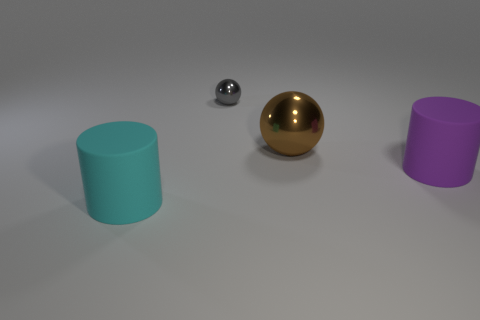Subtract all gray balls. How many balls are left? 1 Add 3 small spheres. How many objects exist? 7 Subtract 2 balls. How many balls are left? 0 Subtract all cyan cylinders. How many yellow spheres are left? 0 Add 3 metal things. How many metal things exist? 5 Subtract 0 green cylinders. How many objects are left? 4 Subtract all gray cylinders. Subtract all gray balls. How many cylinders are left? 2 Subtract all gray objects. Subtract all brown metal balls. How many objects are left? 2 Add 3 large cylinders. How many large cylinders are left? 5 